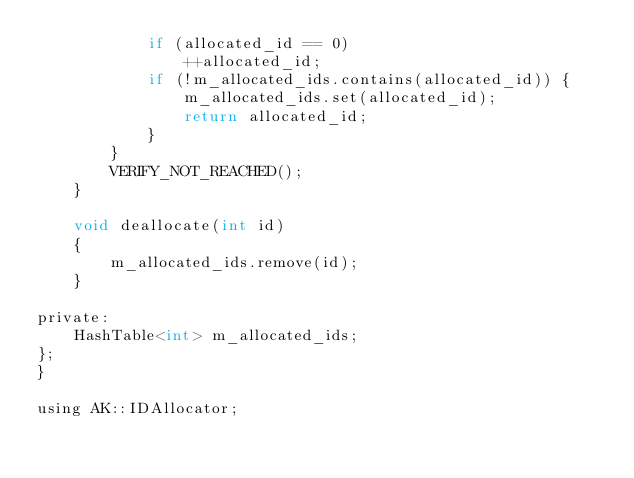<code> <loc_0><loc_0><loc_500><loc_500><_C_>            if (allocated_id == 0)
                ++allocated_id;
            if (!m_allocated_ids.contains(allocated_id)) {
                m_allocated_ids.set(allocated_id);
                return allocated_id;
            }
        }
        VERIFY_NOT_REACHED();
    }

    void deallocate(int id)
    {
        m_allocated_ids.remove(id);
    }

private:
    HashTable<int> m_allocated_ids;
};
}

using AK::IDAllocator;
</code> 